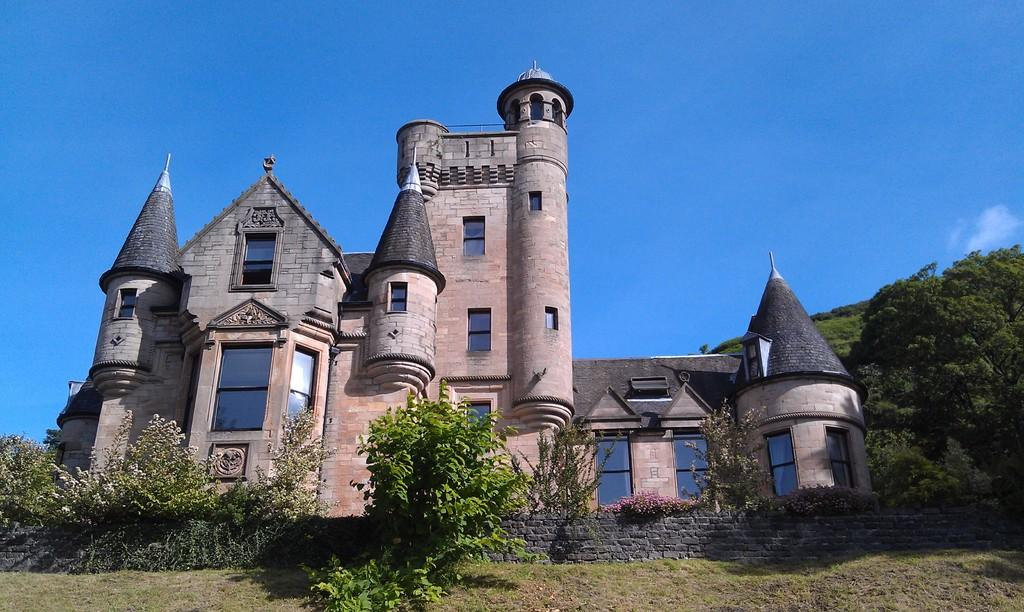What type of structure is present in the image? There is a building in the image. What type of vegetation can be seen in the image? There are trees, plants, and grass in the image. What is the material of the wall in the image? The wall in the image is made of bricks. What can be seen in the background of the image? The sky is visible in the background of the image. Where is the harbor located in the image? There is no harbor present in the image. What type of bomb is visible in the image? There is no bomb present in the image. 